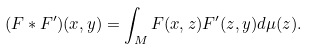<formula> <loc_0><loc_0><loc_500><loc_500>( F * F ^ { \prime } ) ( x , y ) = \int _ { M } F ( x , z ) F ^ { \prime } ( z , y ) d \mu ( z ) .</formula> 